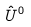Convert formula to latex. <formula><loc_0><loc_0><loc_500><loc_500>\hat { U } ^ { 0 }</formula> 